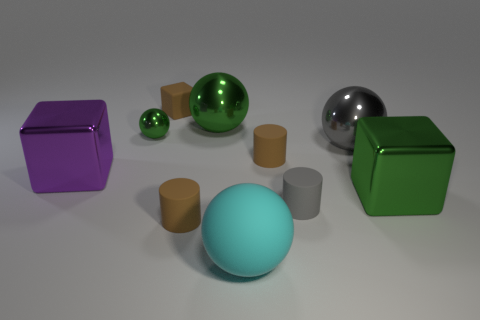Subtract all large green shiny spheres. How many spheres are left? 3 Subtract all green cubes. How many cubes are left? 2 Subtract 0 green cylinders. How many objects are left? 10 Subtract all spheres. How many objects are left? 6 Subtract all blue balls. Subtract all green cubes. How many balls are left? 4 Subtract all gray cylinders. How many cyan balls are left? 1 Subtract all big purple cubes. Subtract all large brown cylinders. How many objects are left? 9 Add 3 shiny objects. How many shiny objects are left? 8 Add 4 cyan matte objects. How many cyan matte objects exist? 5 